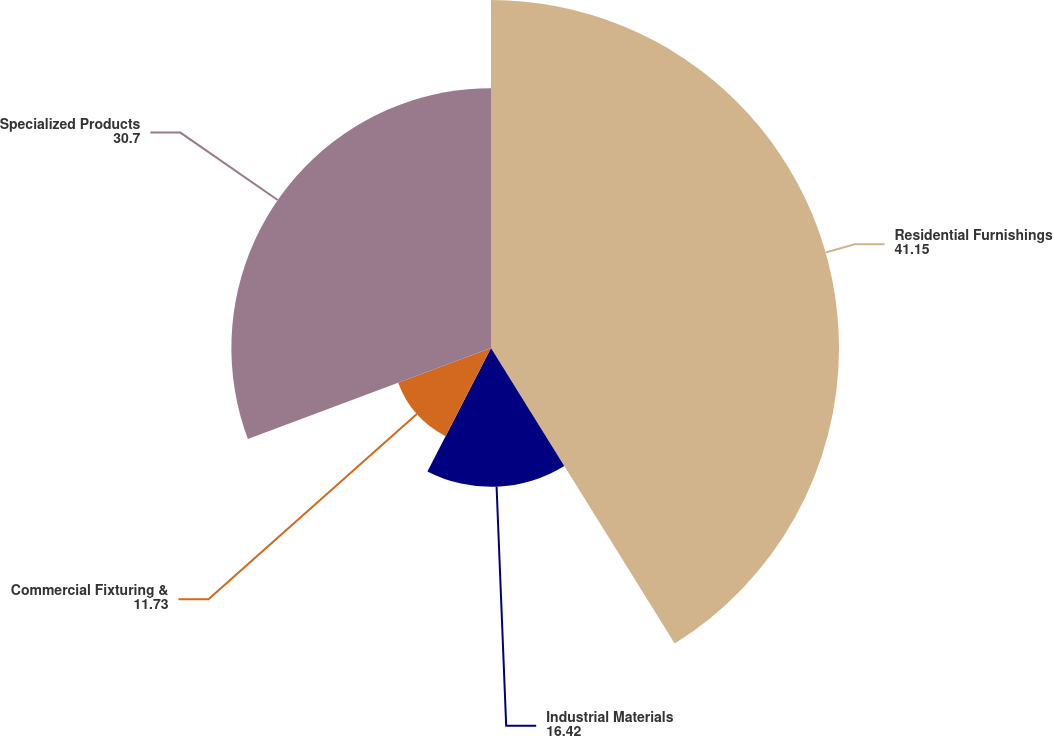<chart> <loc_0><loc_0><loc_500><loc_500><pie_chart><fcel>Residential Furnishings<fcel>Industrial Materials<fcel>Commercial Fixturing &<fcel>Specialized Products<nl><fcel>41.15%<fcel>16.42%<fcel>11.73%<fcel>30.7%<nl></chart> 